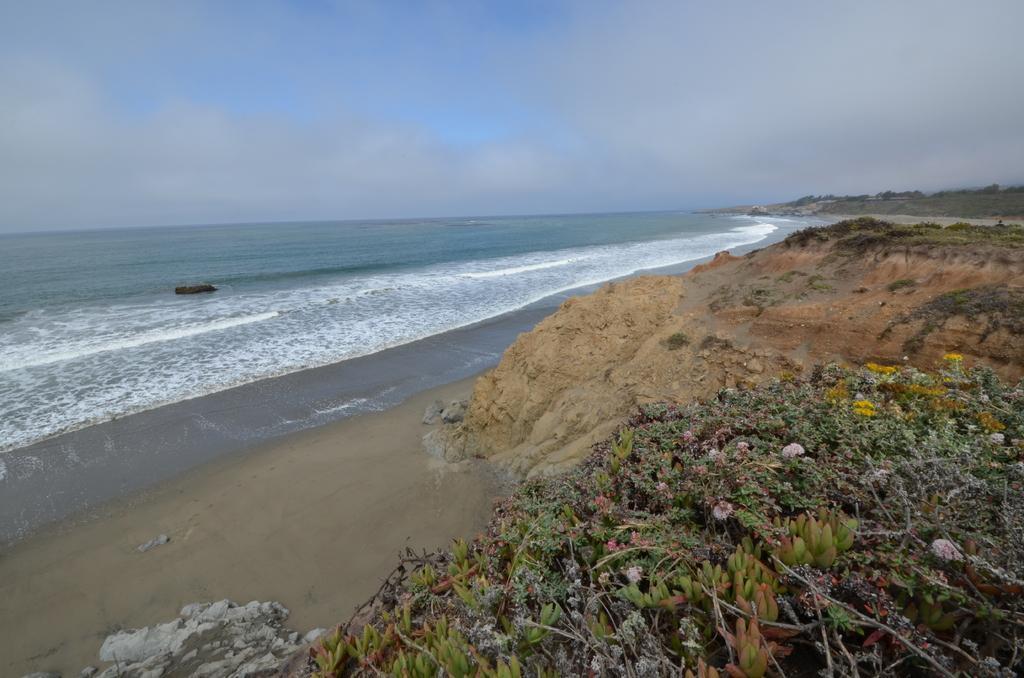Could you give a brief overview of what you see in this image? In this picture we can see the ocean. At the bottom we can see some flowers on the plant. On the right background we can see the trees. At the top we can see the sky and clouds. 